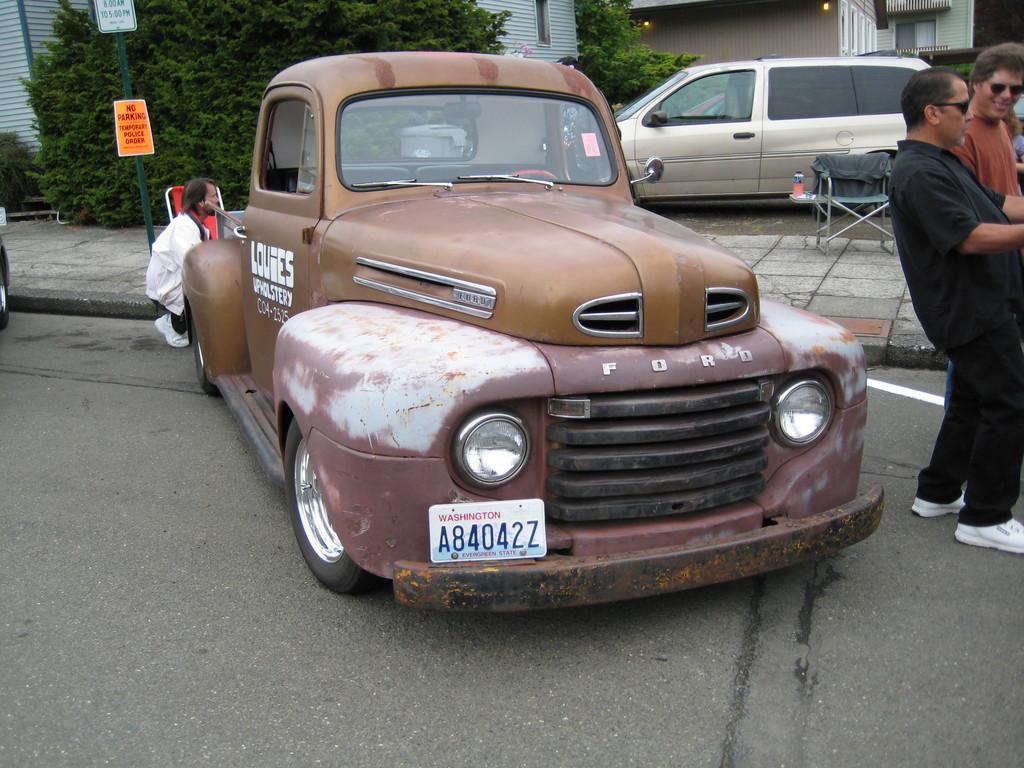Describe this image in one or two sentences. In this image we can see some houses, two lights attached to the wall, some trees, one car on the road, two chairs on the footpath, one man in crouch position, some objects on the table, one person sitting near the house, one tire on the road, two cars parked near the house, two people are standing on the road, one object on the ground, one pipe and one board on the footpath. 